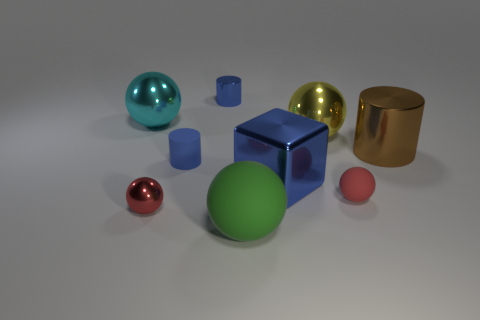Subtract all tiny red shiny spheres. How many spheres are left? 4 Subtract all yellow spheres. How many spheres are left? 4 Subtract all purple balls. Subtract all green cubes. How many balls are left? 5 Subtract all balls. How many objects are left? 4 Subtract all large cyan things. Subtract all large brown metal cylinders. How many objects are left? 7 Add 8 small red matte spheres. How many small red matte spheres are left? 9 Add 2 blue matte objects. How many blue matte objects exist? 3 Subtract 0 yellow blocks. How many objects are left? 9 